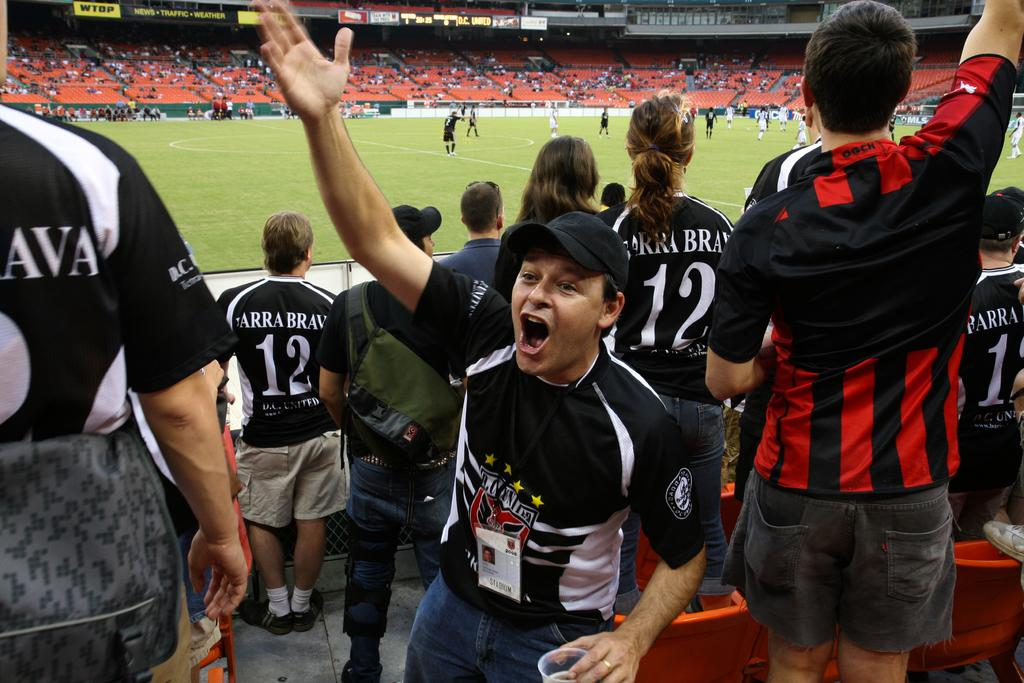Provide a one-sentence caption for the provided image. Many fans in a stadium wear black and white jerseys of Brava #12 and cheer on their team. 